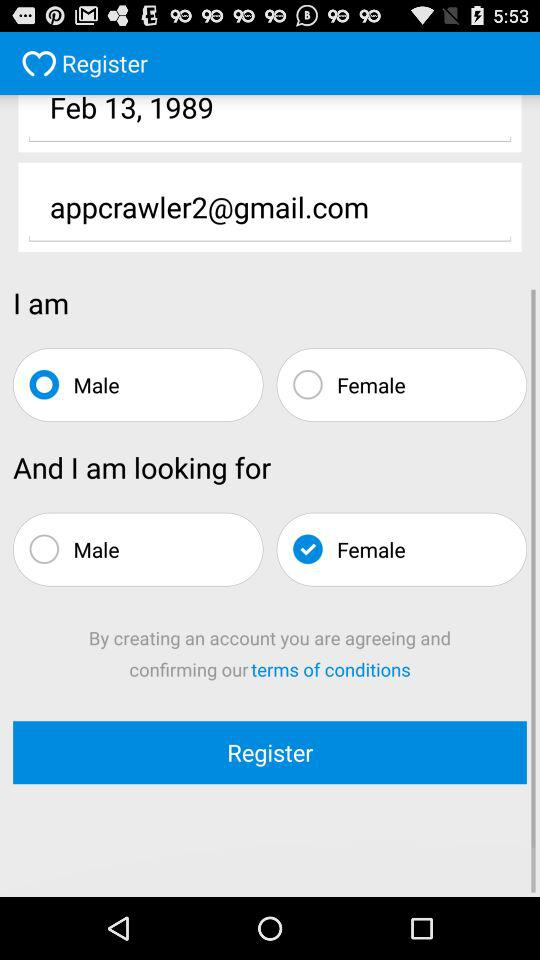What application will receive a public profile, email address, birthday, and photos? The application is "MiuMeet". 